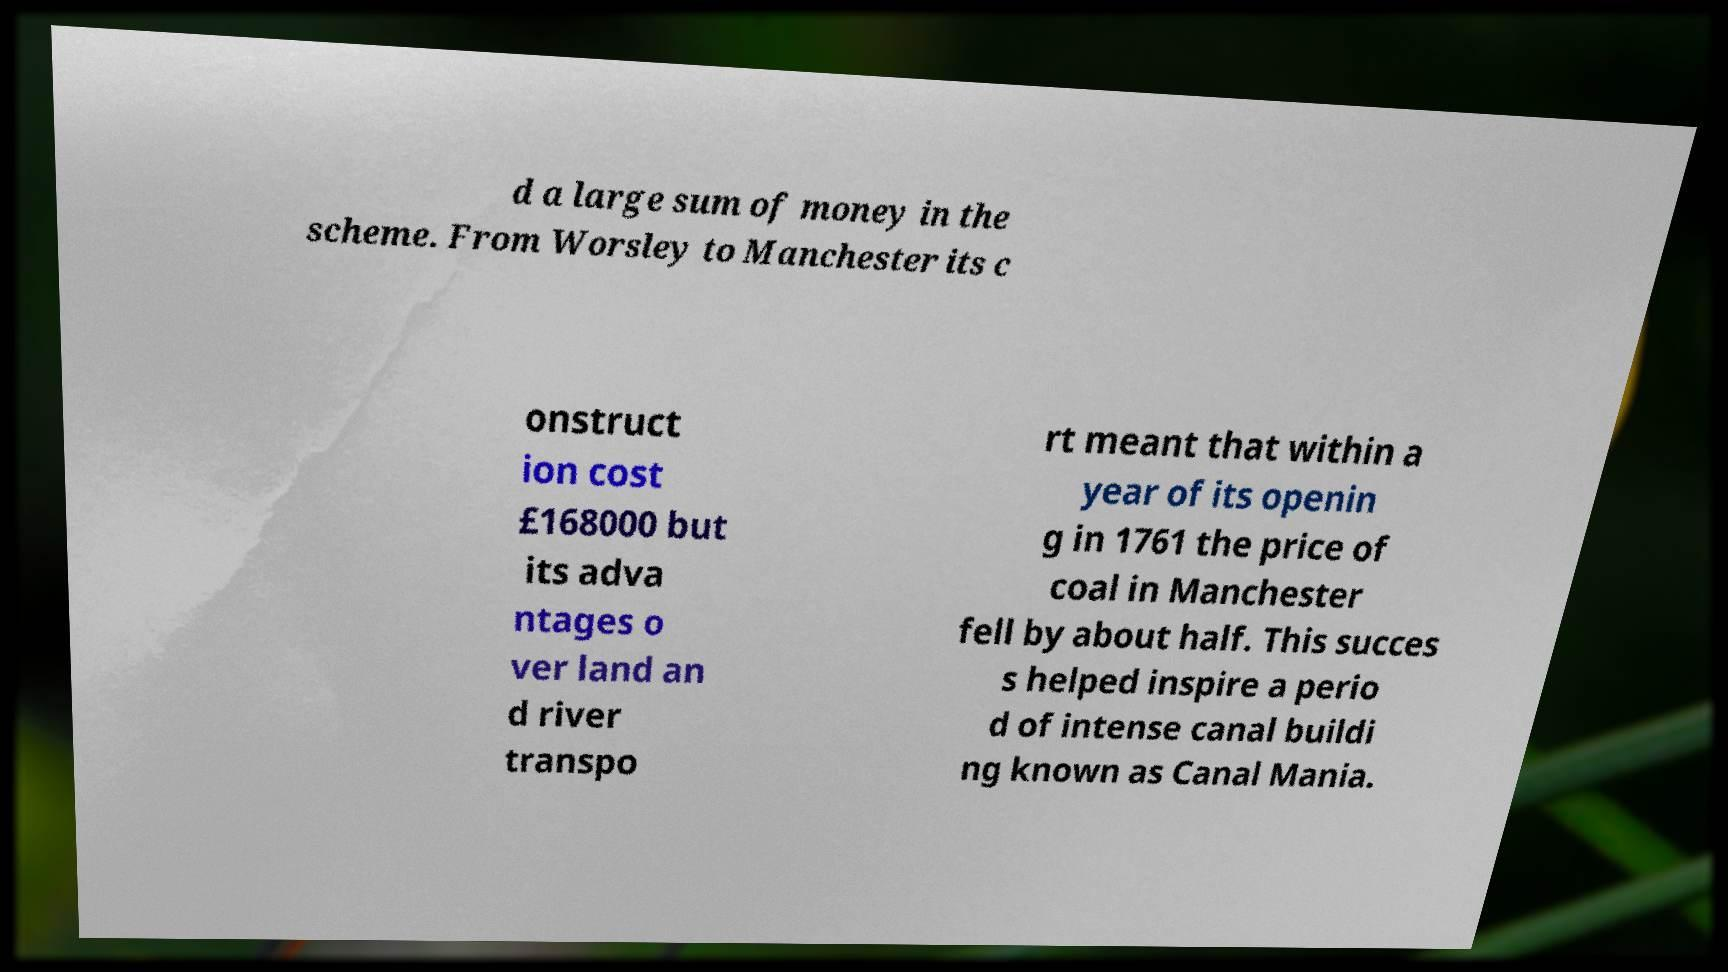There's text embedded in this image that I need extracted. Can you transcribe it verbatim? d a large sum of money in the scheme. From Worsley to Manchester its c onstruct ion cost £168000 but its adva ntages o ver land an d river transpo rt meant that within a year of its openin g in 1761 the price of coal in Manchester fell by about half. This succes s helped inspire a perio d of intense canal buildi ng known as Canal Mania. 